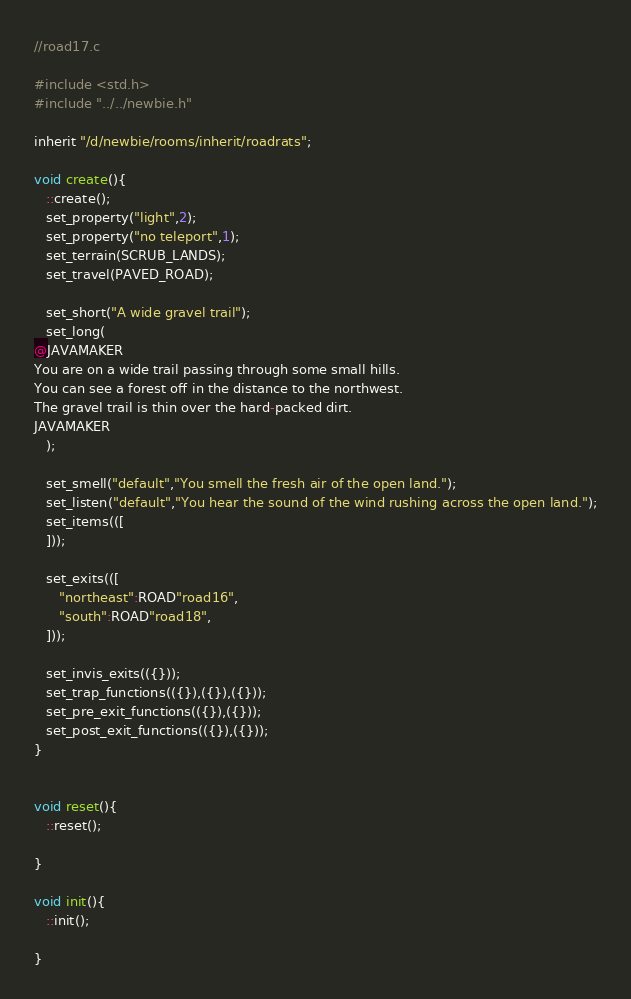<code> <loc_0><loc_0><loc_500><loc_500><_C_>//road17.c

#include <std.h>
#include "../../newbie.h"

inherit "/d/newbie/rooms/inherit/roadrats";

void create(){ 
   ::create();
   set_property("light",2);
   set_property("no teleport",1);
   set_terrain(SCRUB_LANDS);
   set_travel(PAVED_ROAD);

   set_short("A wide gravel trail");
   set_long(
@JAVAMAKER
You are on a wide trail passing through some small hills.
You can see a forest off in the distance to the northwest. 
The gravel trail is thin over the hard-packed dirt.
JAVAMAKER
   );

   set_smell("default","You smell the fresh air of the open land.");
   set_listen("default","You hear the sound of the wind rushing across the open land.");
   set_items(([
   ]));

   set_exits(([
      "northeast":ROAD"road16",
      "south":ROAD"road18",
   ]));

   set_invis_exits(({}));
   set_trap_functions(({}),({}),({}));
   set_pre_exit_functions(({}),({}));
   set_post_exit_functions(({}),({}));
}


void reset(){
   ::reset();

}

void init(){
   ::init();

}







</code> 